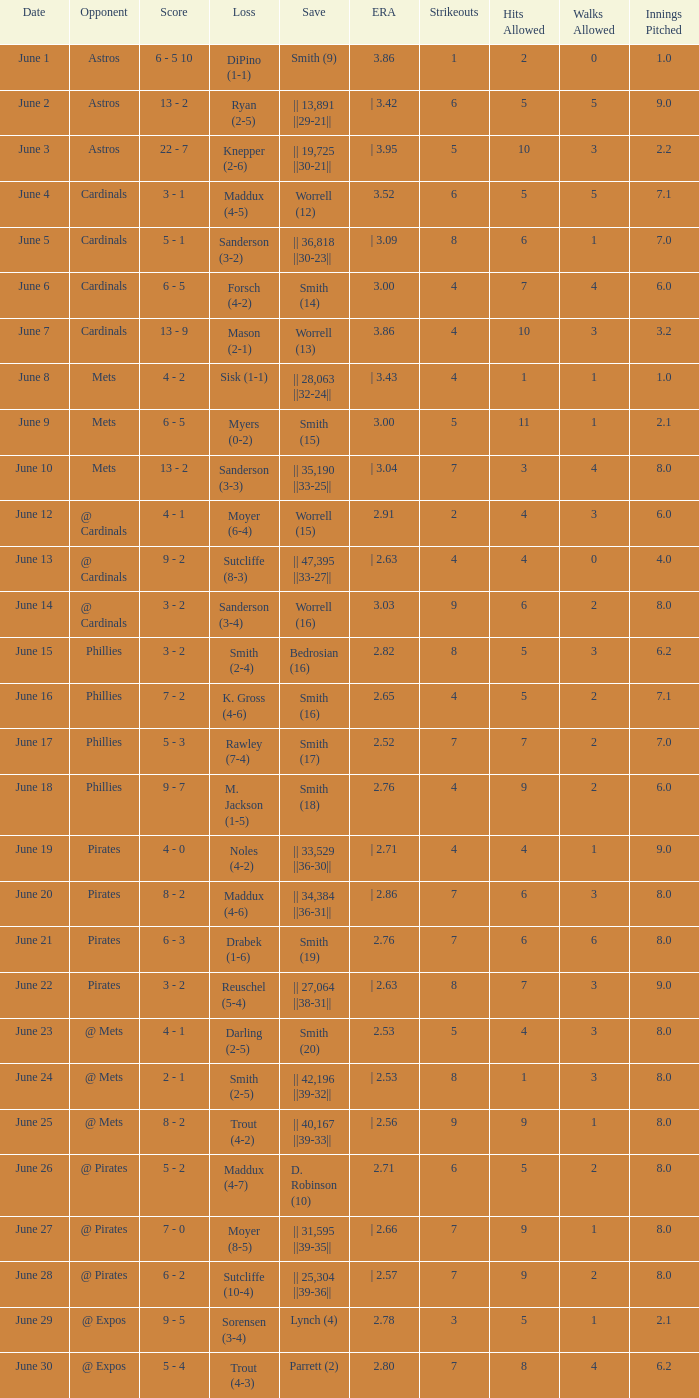On which day did the Chicago Cubs have a loss of trout (4-2)? June 25. 